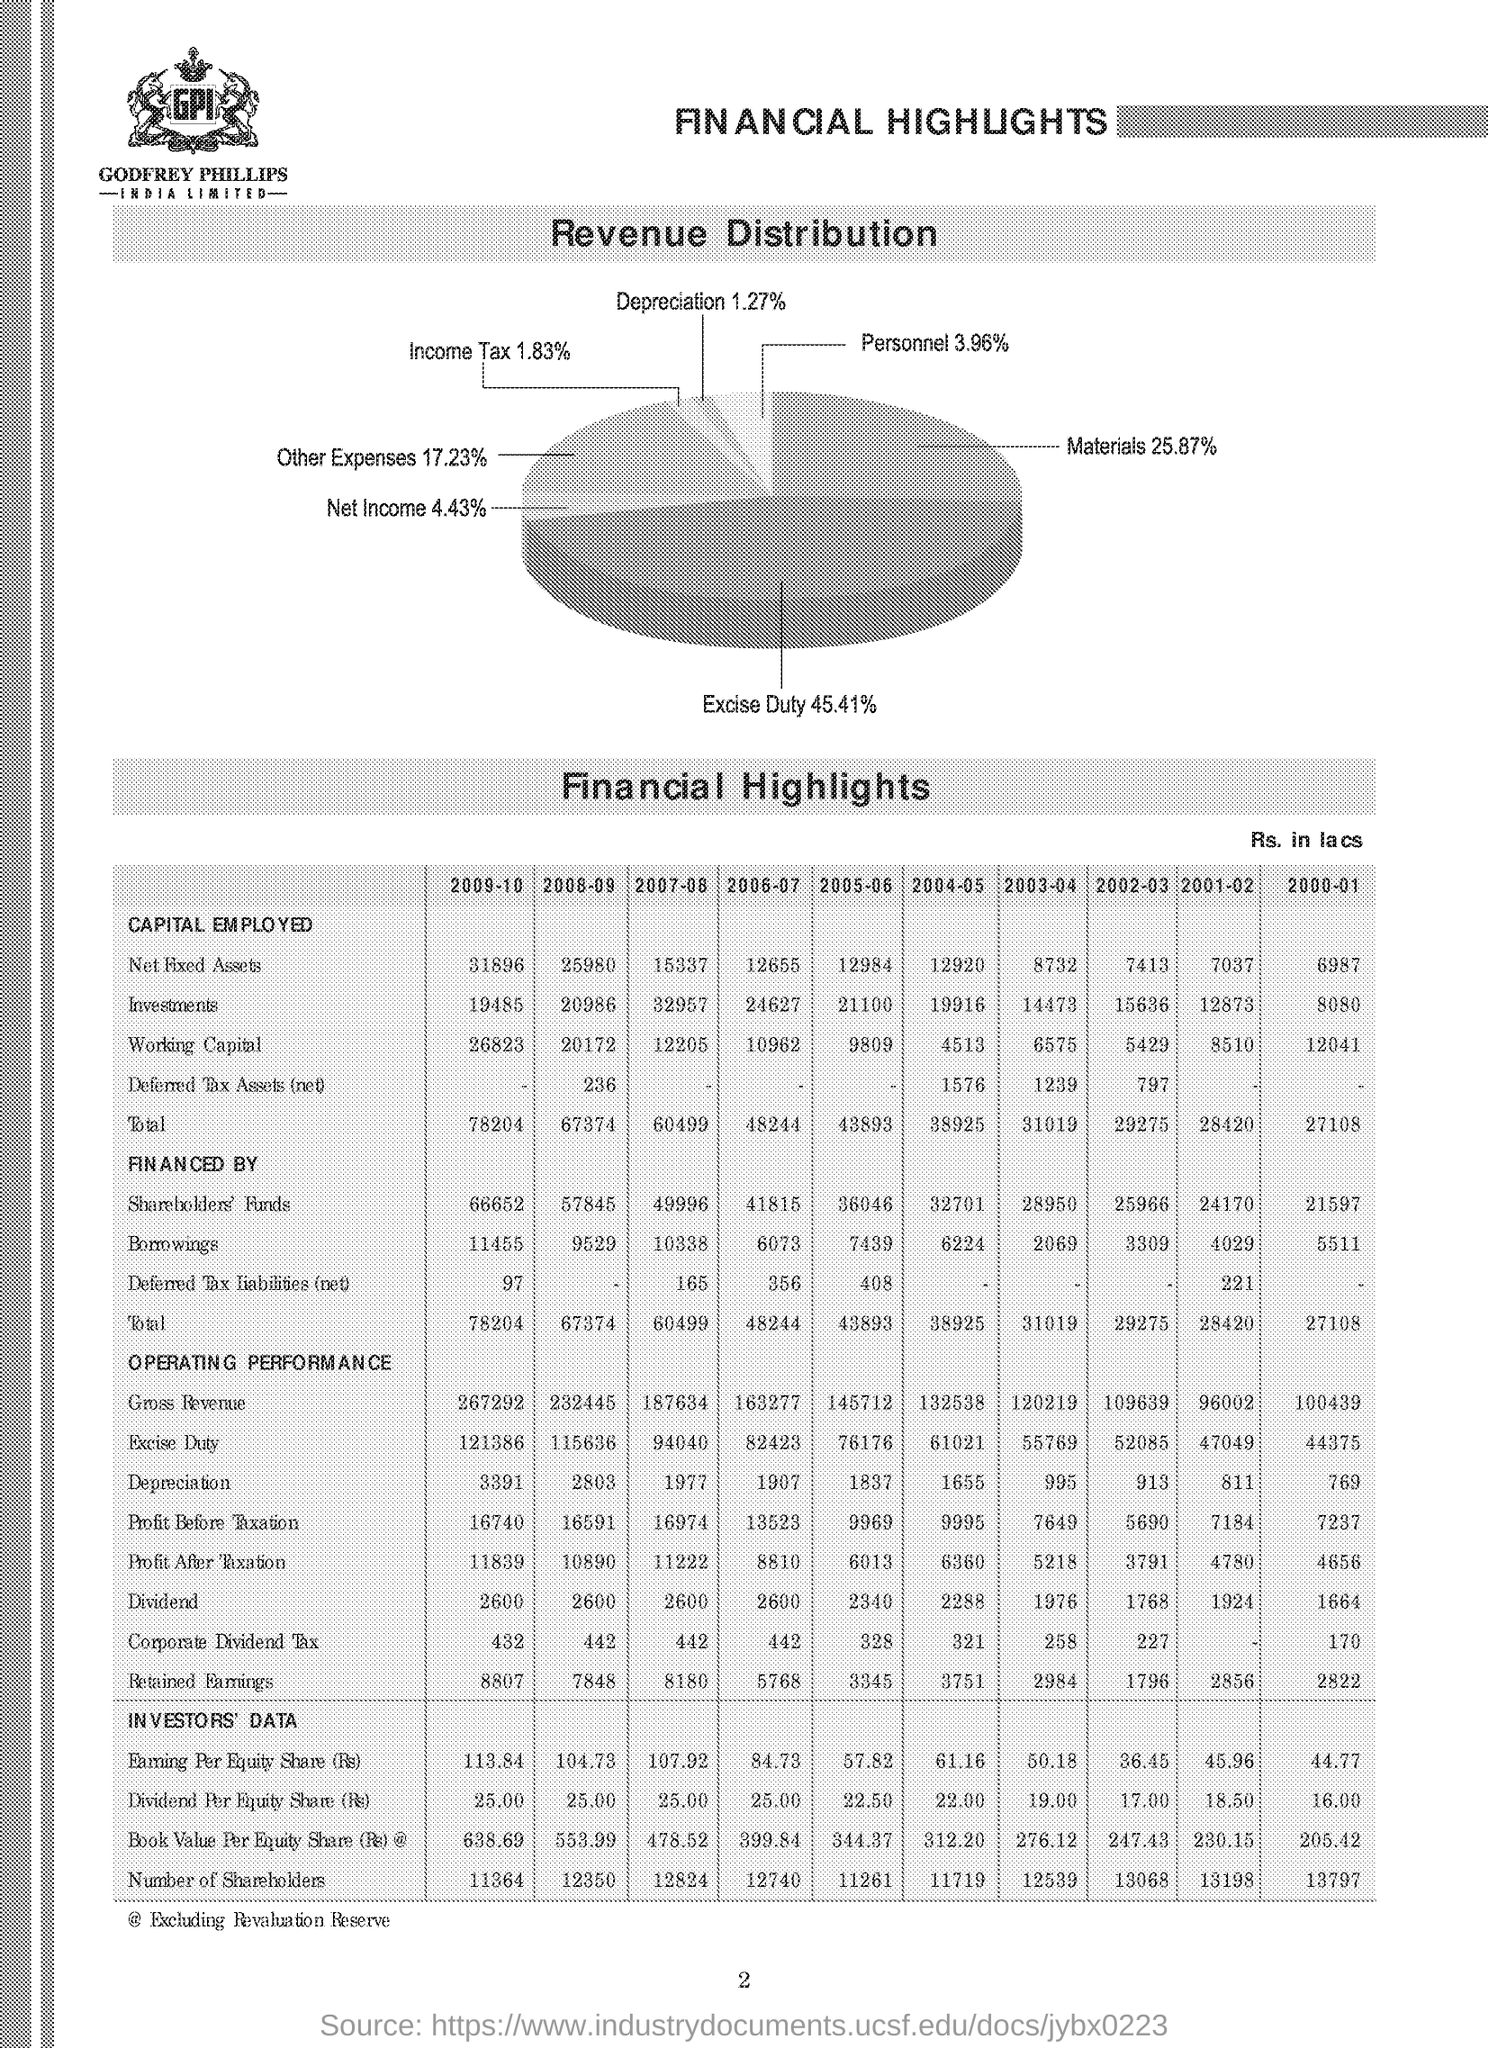What has been the trend in Earnings Per Equity Share (EPS) over the years shown? The trend in Earnings Per Equity Share (EPS) has fluctuated over the years. Starting from 44.77 in 2000-01, there was a general downward trend until a low of 50.18 in 2004-05, and then an increase to a peak of 113.84 in 2009-10. 